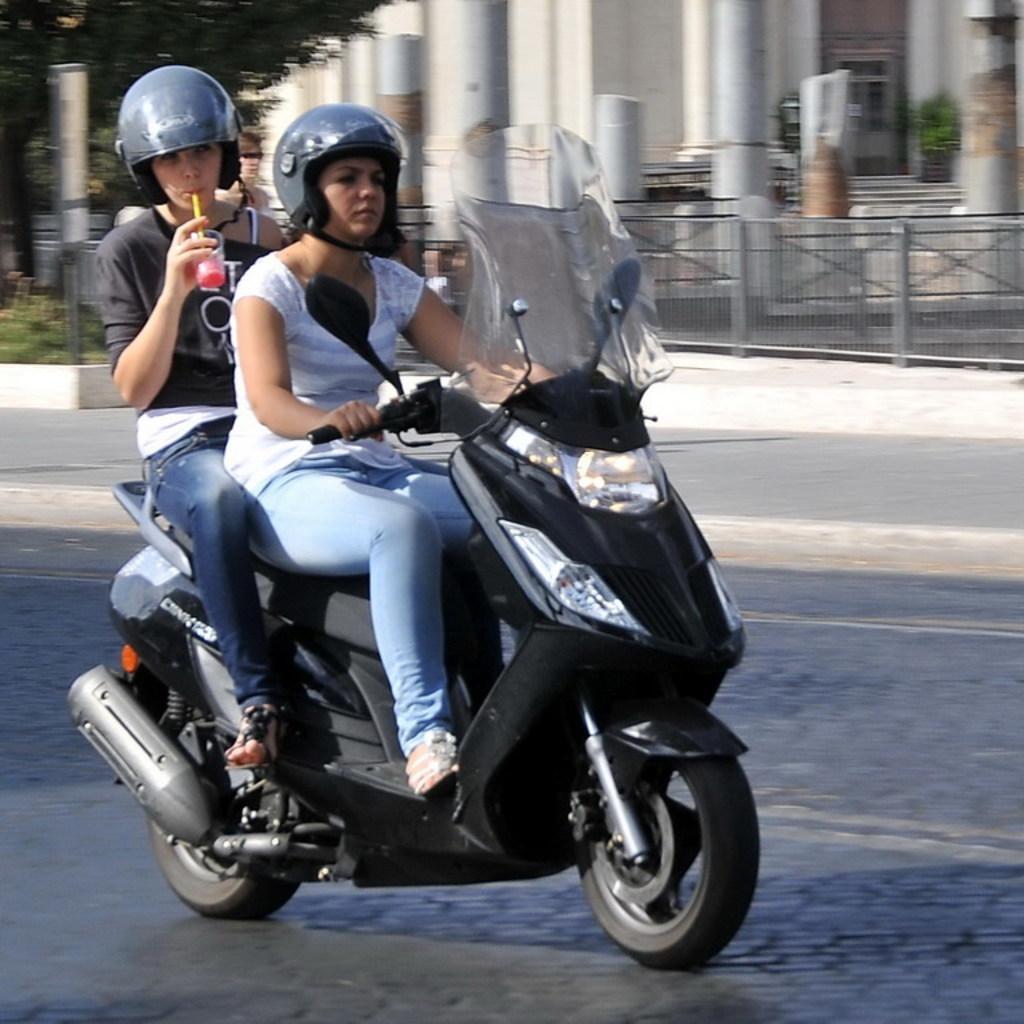Can you describe this image briefly? This is a picture taken in the outdoor. There are two persons sitting on a bike and riding on a road. Behind the people there are pillar and a building. 